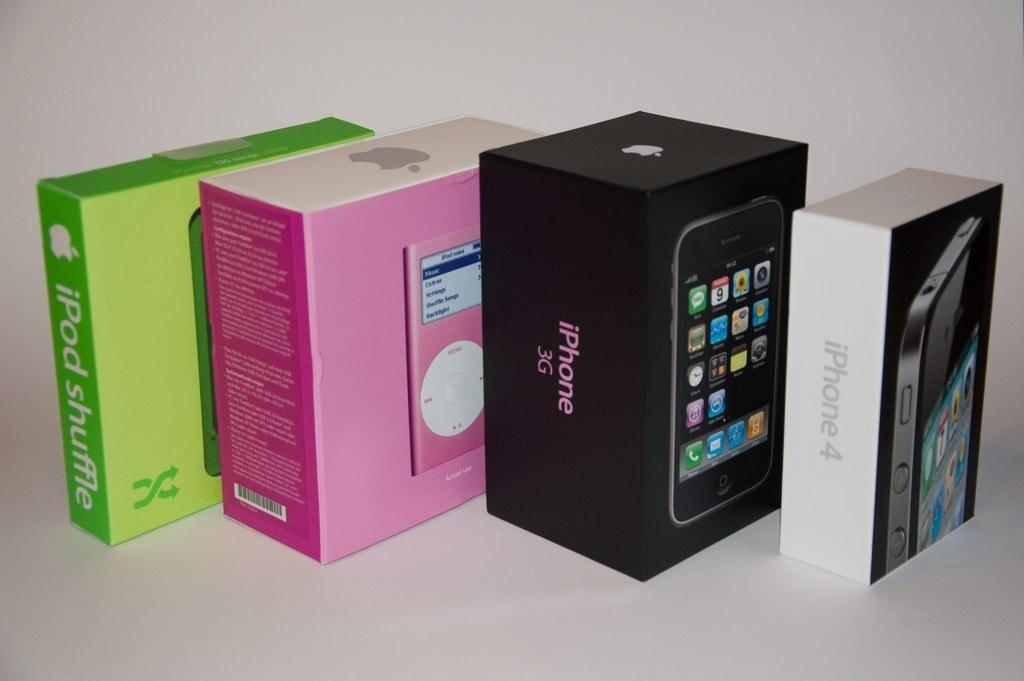<image>
Provide a brief description of the given image. Four different coloured boxes with apple products including iPhone3g. 